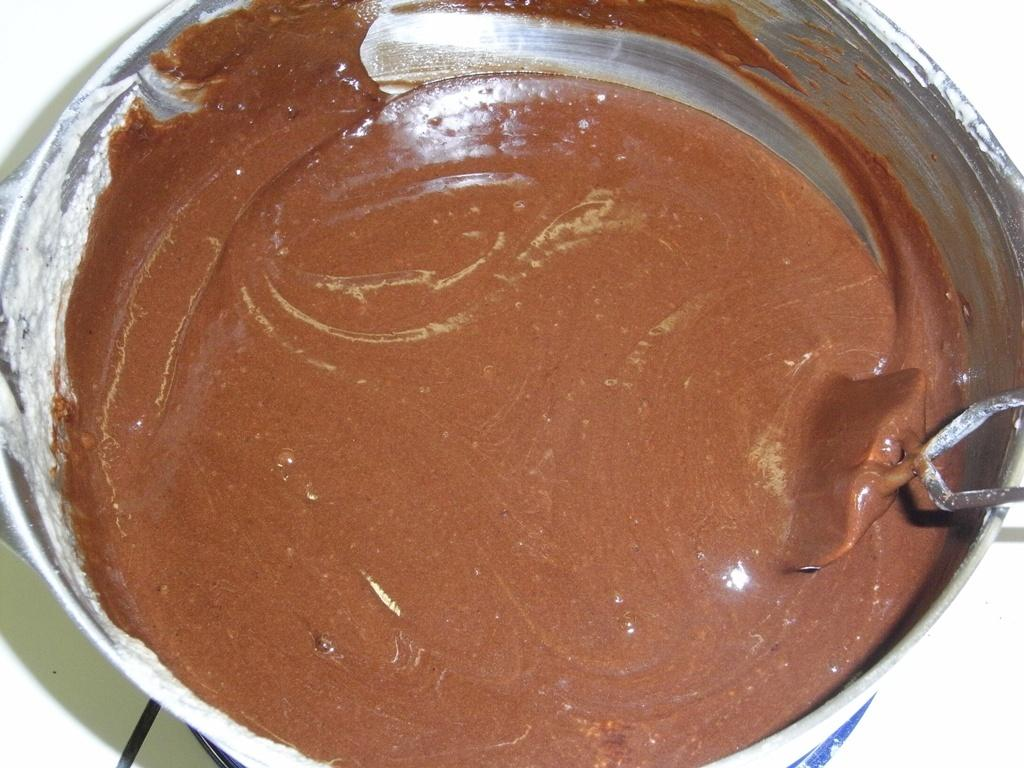What is present in the image? There is a paint in the image. What color is the paint? The paint is in brown color. Is the paint being used for a haircut in the image? No, the paint is not being used for a haircut in the image. Is the paint being used to make oatmeal in the image? No, the paint is not being used to make oatmeal in the image. 